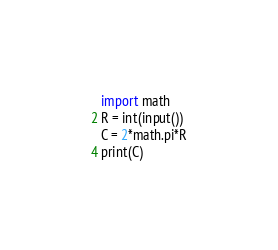Convert code to text. <code><loc_0><loc_0><loc_500><loc_500><_Python_>import math
R = int(input())
C = 2*math.pi*R
print(C)</code> 